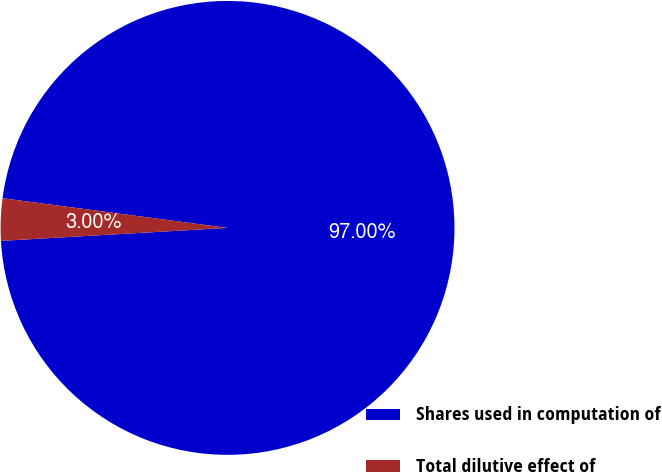Convert chart. <chart><loc_0><loc_0><loc_500><loc_500><pie_chart><fcel>Shares used in computation of<fcel>Total dilutive effect of<nl><fcel>97.0%<fcel>3.0%<nl></chart> 